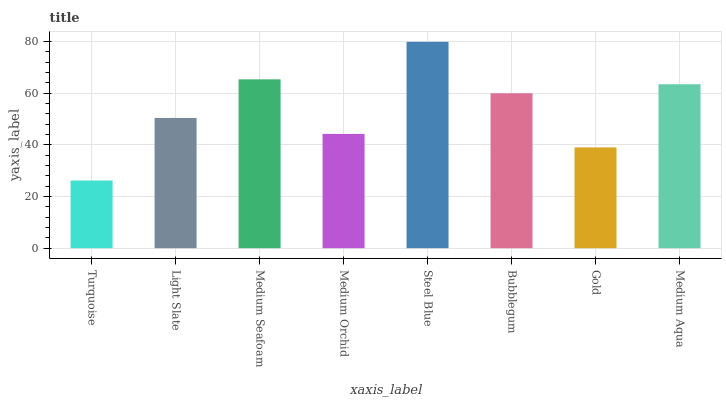Is Turquoise the minimum?
Answer yes or no. Yes. Is Steel Blue the maximum?
Answer yes or no. Yes. Is Light Slate the minimum?
Answer yes or no. No. Is Light Slate the maximum?
Answer yes or no. No. Is Light Slate greater than Turquoise?
Answer yes or no. Yes. Is Turquoise less than Light Slate?
Answer yes or no. Yes. Is Turquoise greater than Light Slate?
Answer yes or no. No. Is Light Slate less than Turquoise?
Answer yes or no. No. Is Bubblegum the high median?
Answer yes or no. Yes. Is Light Slate the low median?
Answer yes or no. Yes. Is Turquoise the high median?
Answer yes or no. No. Is Medium Seafoam the low median?
Answer yes or no. No. 